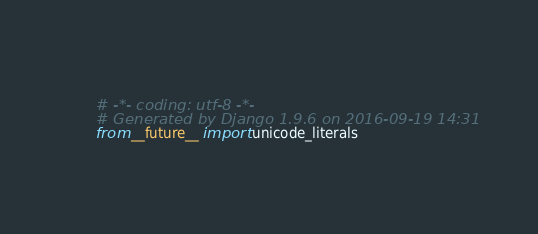Convert code to text. <code><loc_0><loc_0><loc_500><loc_500><_Python_># -*- coding: utf-8 -*-
# Generated by Django 1.9.6 on 2016-09-19 14:31
from __future__ import unicode_literals
</code> 